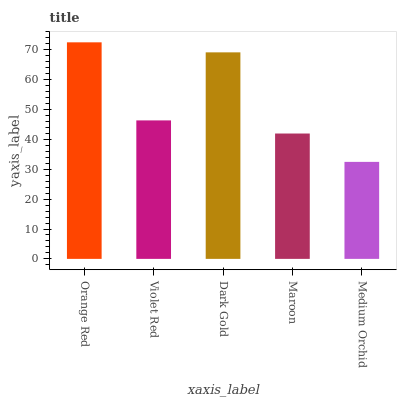Is Medium Orchid the minimum?
Answer yes or no. Yes. Is Orange Red the maximum?
Answer yes or no. Yes. Is Violet Red the minimum?
Answer yes or no. No. Is Violet Red the maximum?
Answer yes or no. No. Is Orange Red greater than Violet Red?
Answer yes or no. Yes. Is Violet Red less than Orange Red?
Answer yes or no. Yes. Is Violet Red greater than Orange Red?
Answer yes or no. No. Is Orange Red less than Violet Red?
Answer yes or no. No. Is Violet Red the high median?
Answer yes or no. Yes. Is Violet Red the low median?
Answer yes or no. Yes. Is Dark Gold the high median?
Answer yes or no. No. Is Dark Gold the low median?
Answer yes or no. No. 